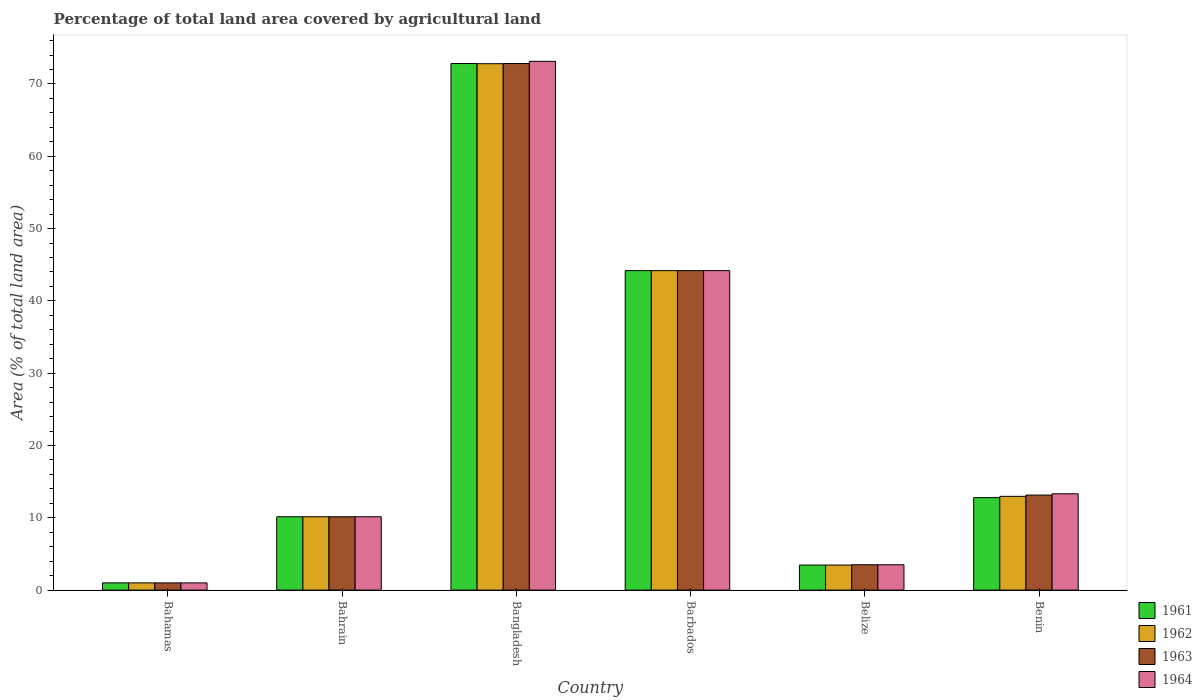Are the number of bars on each tick of the X-axis equal?
Provide a short and direct response. Yes. What is the label of the 1st group of bars from the left?
Keep it short and to the point. Bahamas. What is the percentage of agricultural land in 1962 in Barbados?
Offer a very short reply. 44.19. Across all countries, what is the maximum percentage of agricultural land in 1963?
Give a very brief answer. 72.83. Across all countries, what is the minimum percentage of agricultural land in 1964?
Your answer should be compact. 1. In which country was the percentage of agricultural land in 1964 maximum?
Keep it short and to the point. Bangladesh. In which country was the percentage of agricultural land in 1961 minimum?
Keep it short and to the point. Bahamas. What is the total percentage of agricultural land in 1961 in the graph?
Your answer should be compact. 144.41. What is the difference between the percentage of agricultural land in 1962 in Bahamas and that in Bangladesh?
Your answer should be very brief. -71.81. What is the difference between the percentage of agricultural land in 1962 in Belize and the percentage of agricultural land in 1964 in Bangladesh?
Your answer should be very brief. -69.67. What is the average percentage of agricultural land in 1964 per country?
Your response must be concise. 24.22. What is the ratio of the percentage of agricultural land in 1963 in Bangladesh to that in Benin?
Offer a terse response. 5.54. What is the difference between the highest and the second highest percentage of agricultural land in 1961?
Make the answer very short. 28.64. What is the difference between the highest and the lowest percentage of agricultural land in 1963?
Provide a short and direct response. 71.83. In how many countries, is the percentage of agricultural land in 1961 greater than the average percentage of agricultural land in 1961 taken over all countries?
Your answer should be compact. 2. Is the sum of the percentage of agricultural land in 1961 in Bangladesh and Barbados greater than the maximum percentage of agricultural land in 1964 across all countries?
Your answer should be compact. Yes. Is it the case that in every country, the sum of the percentage of agricultural land in 1961 and percentage of agricultural land in 1963 is greater than the sum of percentage of agricultural land in 1962 and percentage of agricultural land in 1964?
Your answer should be compact. No. Is it the case that in every country, the sum of the percentage of agricultural land in 1962 and percentage of agricultural land in 1964 is greater than the percentage of agricultural land in 1963?
Your response must be concise. Yes. What is the difference between two consecutive major ticks on the Y-axis?
Make the answer very short. 10. Are the values on the major ticks of Y-axis written in scientific E-notation?
Your answer should be compact. No. Does the graph contain any zero values?
Provide a short and direct response. No. Does the graph contain grids?
Your answer should be very brief. No. Where does the legend appear in the graph?
Ensure brevity in your answer.  Bottom right. How many legend labels are there?
Make the answer very short. 4. What is the title of the graph?
Give a very brief answer. Percentage of total land area covered by agricultural land. What is the label or title of the X-axis?
Provide a short and direct response. Country. What is the label or title of the Y-axis?
Ensure brevity in your answer.  Area (% of total land area). What is the Area (% of total land area) in 1961 in Bahamas?
Ensure brevity in your answer.  1. What is the Area (% of total land area) in 1962 in Bahamas?
Provide a succinct answer. 1. What is the Area (% of total land area) of 1963 in Bahamas?
Offer a very short reply. 1. What is the Area (% of total land area) in 1964 in Bahamas?
Keep it short and to the point. 1. What is the Area (% of total land area) in 1961 in Bahrain?
Your answer should be very brief. 10.14. What is the Area (% of total land area) of 1962 in Bahrain?
Keep it short and to the point. 10.14. What is the Area (% of total land area) of 1963 in Bahrain?
Provide a succinct answer. 10.14. What is the Area (% of total land area) in 1964 in Bahrain?
Your answer should be compact. 10.14. What is the Area (% of total land area) in 1961 in Bangladesh?
Your answer should be compact. 72.83. What is the Area (% of total land area) of 1962 in Bangladesh?
Provide a short and direct response. 72.8. What is the Area (% of total land area) of 1963 in Bangladesh?
Make the answer very short. 72.83. What is the Area (% of total land area) of 1964 in Bangladesh?
Offer a terse response. 73.14. What is the Area (% of total land area) of 1961 in Barbados?
Your answer should be very brief. 44.19. What is the Area (% of total land area) of 1962 in Barbados?
Offer a terse response. 44.19. What is the Area (% of total land area) in 1963 in Barbados?
Provide a succinct answer. 44.19. What is the Area (% of total land area) in 1964 in Barbados?
Offer a terse response. 44.19. What is the Area (% of total land area) of 1961 in Belize?
Give a very brief answer. 3.46. What is the Area (% of total land area) of 1962 in Belize?
Offer a terse response. 3.46. What is the Area (% of total land area) of 1963 in Belize?
Provide a succinct answer. 3.51. What is the Area (% of total land area) in 1964 in Belize?
Your response must be concise. 3.51. What is the Area (% of total land area) in 1961 in Benin?
Provide a short and direct response. 12.79. What is the Area (% of total land area) of 1962 in Benin?
Provide a succinct answer. 12.97. What is the Area (% of total land area) in 1963 in Benin?
Your response must be concise. 13.14. What is the Area (% of total land area) in 1964 in Benin?
Provide a succinct answer. 13.32. Across all countries, what is the maximum Area (% of total land area) in 1961?
Keep it short and to the point. 72.83. Across all countries, what is the maximum Area (% of total land area) of 1962?
Provide a short and direct response. 72.8. Across all countries, what is the maximum Area (% of total land area) in 1963?
Offer a very short reply. 72.83. Across all countries, what is the maximum Area (% of total land area) of 1964?
Provide a succinct answer. 73.14. Across all countries, what is the minimum Area (% of total land area) of 1961?
Provide a short and direct response. 1. Across all countries, what is the minimum Area (% of total land area) in 1962?
Your answer should be compact. 1. Across all countries, what is the minimum Area (% of total land area) in 1963?
Provide a succinct answer. 1. Across all countries, what is the minimum Area (% of total land area) of 1964?
Ensure brevity in your answer.  1. What is the total Area (% of total land area) of 1961 in the graph?
Your response must be concise. 144.41. What is the total Area (% of total land area) in 1962 in the graph?
Ensure brevity in your answer.  144.56. What is the total Area (% of total land area) in 1963 in the graph?
Provide a succinct answer. 144.81. What is the total Area (% of total land area) in 1964 in the graph?
Your answer should be compact. 145.29. What is the difference between the Area (% of total land area) of 1961 in Bahamas and that in Bahrain?
Your answer should be very brief. -9.15. What is the difference between the Area (% of total land area) of 1962 in Bahamas and that in Bahrain?
Make the answer very short. -9.15. What is the difference between the Area (% of total land area) of 1963 in Bahamas and that in Bahrain?
Your response must be concise. -9.15. What is the difference between the Area (% of total land area) of 1964 in Bahamas and that in Bahrain?
Provide a succinct answer. -9.15. What is the difference between the Area (% of total land area) in 1961 in Bahamas and that in Bangladesh?
Provide a short and direct response. -71.83. What is the difference between the Area (% of total land area) of 1962 in Bahamas and that in Bangladesh?
Offer a very short reply. -71.81. What is the difference between the Area (% of total land area) in 1963 in Bahamas and that in Bangladesh?
Offer a very short reply. -71.83. What is the difference between the Area (% of total land area) in 1964 in Bahamas and that in Bangladesh?
Make the answer very short. -72.14. What is the difference between the Area (% of total land area) of 1961 in Bahamas and that in Barbados?
Offer a terse response. -43.19. What is the difference between the Area (% of total land area) of 1962 in Bahamas and that in Barbados?
Give a very brief answer. -43.19. What is the difference between the Area (% of total land area) in 1963 in Bahamas and that in Barbados?
Keep it short and to the point. -43.19. What is the difference between the Area (% of total land area) of 1964 in Bahamas and that in Barbados?
Your response must be concise. -43.19. What is the difference between the Area (% of total land area) of 1961 in Bahamas and that in Belize?
Provide a short and direct response. -2.46. What is the difference between the Area (% of total land area) in 1962 in Bahamas and that in Belize?
Your answer should be compact. -2.46. What is the difference between the Area (% of total land area) in 1963 in Bahamas and that in Belize?
Give a very brief answer. -2.51. What is the difference between the Area (% of total land area) in 1964 in Bahamas and that in Belize?
Your answer should be compact. -2.51. What is the difference between the Area (% of total land area) in 1961 in Bahamas and that in Benin?
Make the answer very short. -11.79. What is the difference between the Area (% of total land area) of 1962 in Bahamas and that in Benin?
Provide a short and direct response. -11.97. What is the difference between the Area (% of total land area) in 1963 in Bahamas and that in Benin?
Give a very brief answer. -12.14. What is the difference between the Area (% of total land area) in 1964 in Bahamas and that in Benin?
Keep it short and to the point. -12.32. What is the difference between the Area (% of total land area) in 1961 in Bahrain and that in Bangladesh?
Give a very brief answer. -62.68. What is the difference between the Area (% of total land area) in 1962 in Bahrain and that in Bangladesh?
Ensure brevity in your answer.  -62.66. What is the difference between the Area (% of total land area) of 1963 in Bahrain and that in Bangladesh?
Keep it short and to the point. -62.68. What is the difference between the Area (% of total land area) of 1964 in Bahrain and that in Bangladesh?
Make the answer very short. -62.99. What is the difference between the Area (% of total land area) in 1961 in Bahrain and that in Barbados?
Offer a terse response. -34.04. What is the difference between the Area (% of total land area) in 1962 in Bahrain and that in Barbados?
Your answer should be compact. -34.04. What is the difference between the Area (% of total land area) in 1963 in Bahrain and that in Barbados?
Your response must be concise. -34.04. What is the difference between the Area (% of total land area) of 1964 in Bahrain and that in Barbados?
Give a very brief answer. -34.04. What is the difference between the Area (% of total land area) in 1961 in Bahrain and that in Belize?
Make the answer very short. 6.68. What is the difference between the Area (% of total land area) in 1962 in Bahrain and that in Belize?
Offer a terse response. 6.68. What is the difference between the Area (% of total land area) of 1963 in Bahrain and that in Belize?
Provide a short and direct response. 6.64. What is the difference between the Area (% of total land area) of 1964 in Bahrain and that in Belize?
Give a very brief answer. 6.64. What is the difference between the Area (% of total land area) of 1961 in Bahrain and that in Benin?
Make the answer very short. -2.64. What is the difference between the Area (% of total land area) of 1962 in Bahrain and that in Benin?
Keep it short and to the point. -2.82. What is the difference between the Area (% of total land area) in 1963 in Bahrain and that in Benin?
Provide a succinct answer. -3. What is the difference between the Area (% of total land area) of 1964 in Bahrain and that in Benin?
Offer a very short reply. -3.18. What is the difference between the Area (% of total land area) in 1961 in Bangladesh and that in Barbados?
Your response must be concise. 28.64. What is the difference between the Area (% of total land area) of 1962 in Bangladesh and that in Barbados?
Give a very brief answer. 28.62. What is the difference between the Area (% of total land area) in 1963 in Bangladesh and that in Barbados?
Make the answer very short. 28.64. What is the difference between the Area (% of total land area) in 1964 in Bangladesh and that in Barbados?
Your answer should be very brief. 28.95. What is the difference between the Area (% of total land area) in 1961 in Bangladesh and that in Belize?
Keep it short and to the point. 69.36. What is the difference between the Area (% of total land area) of 1962 in Bangladesh and that in Belize?
Give a very brief answer. 69.34. What is the difference between the Area (% of total land area) of 1963 in Bangladesh and that in Belize?
Keep it short and to the point. 69.32. What is the difference between the Area (% of total land area) in 1964 in Bangladesh and that in Belize?
Your response must be concise. 69.63. What is the difference between the Area (% of total land area) of 1961 in Bangladesh and that in Benin?
Make the answer very short. 60.04. What is the difference between the Area (% of total land area) of 1962 in Bangladesh and that in Benin?
Provide a short and direct response. 59.84. What is the difference between the Area (% of total land area) of 1963 in Bangladesh and that in Benin?
Provide a short and direct response. 59.68. What is the difference between the Area (% of total land area) in 1964 in Bangladesh and that in Benin?
Your answer should be compact. 59.81. What is the difference between the Area (% of total land area) of 1961 in Barbados and that in Belize?
Offer a very short reply. 40.72. What is the difference between the Area (% of total land area) of 1962 in Barbados and that in Belize?
Give a very brief answer. 40.72. What is the difference between the Area (% of total land area) in 1963 in Barbados and that in Belize?
Offer a terse response. 40.68. What is the difference between the Area (% of total land area) in 1964 in Barbados and that in Belize?
Your response must be concise. 40.68. What is the difference between the Area (% of total land area) in 1961 in Barbados and that in Benin?
Offer a very short reply. 31.4. What is the difference between the Area (% of total land area) of 1962 in Barbados and that in Benin?
Your answer should be very brief. 31.22. What is the difference between the Area (% of total land area) of 1963 in Barbados and that in Benin?
Offer a very short reply. 31.04. What is the difference between the Area (% of total land area) of 1964 in Barbados and that in Benin?
Make the answer very short. 30.87. What is the difference between the Area (% of total land area) in 1961 in Belize and that in Benin?
Keep it short and to the point. -9.32. What is the difference between the Area (% of total land area) in 1962 in Belize and that in Benin?
Give a very brief answer. -9.5. What is the difference between the Area (% of total land area) of 1963 in Belize and that in Benin?
Make the answer very short. -9.64. What is the difference between the Area (% of total land area) of 1964 in Belize and that in Benin?
Offer a very short reply. -9.81. What is the difference between the Area (% of total land area) in 1961 in Bahamas and the Area (% of total land area) in 1962 in Bahrain?
Your answer should be very brief. -9.15. What is the difference between the Area (% of total land area) in 1961 in Bahamas and the Area (% of total land area) in 1963 in Bahrain?
Give a very brief answer. -9.15. What is the difference between the Area (% of total land area) in 1961 in Bahamas and the Area (% of total land area) in 1964 in Bahrain?
Offer a very short reply. -9.15. What is the difference between the Area (% of total land area) in 1962 in Bahamas and the Area (% of total land area) in 1963 in Bahrain?
Provide a short and direct response. -9.15. What is the difference between the Area (% of total land area) in 1962 in Bahamas and the Area (% of total land area) in 1964 in Bahrain?
Your answer should be compact. -9.15. What is the difference between the Area (% of total land area) of 1963 in Bahamas and the Area (% of total land area) of 1964 in Bahrain?
Keep it short and to the point. -9.15. What is the difference between the Area (% of total land area) in 1961 in Bahamas and the Area (% of total land area) in 1962 in Bangladesh?
Provide a short and direct response. -71.81. What is the difference between the Area (% of total land area) in 1961 in Bahamas and the Area (% of total land area) in 1963 in Bangladesh?
Offer a terse response. -71.83. What is the difference between the Area (% of total land area) of 1961 in Bahamas and the Area (% of total land area) of 1964 in Bangladesh?
Keep it short and to the point. -72.14. What is the difference between the Area (% of total land area) of 1962 in Bahamas and the Area (% of total land area) of 1963 in Bangladesh?
Your answer should be very brief. -71.83. What is the difference between the Area (% of total land area) in 1962 in Bahamas and the Area (% of total land area) in 1964 in Bangladesh?
Your answer should be compact. -72.14. What is the difference between the Area (% of total land area) of 1963 in Bahamas and the Area (% of total land area) of 1964 in Bangladesh?
Offer a terse response. -72.14. What is the difference between the Area (% of total land area) of 1961 in Bahamas and the Area (% of total land area) of 1962 in Barbados?
Provide a succinct answer. -43.19. What is the difference between the Area (% of total land area) in 1961 in Bahamas and the Area (% of total land area) in 1963 in Barbados?
Provide a short and direct response. -43.19. What is the difference between the Area (% of total land area) of 1961 in Bahamas and the Area (% of total land area) of 1964 in Barbados?
Ensure brevity in your answer.  -43.19. What is the difference between the Area (% of total land area) in 1962 in Bahamas and the Area (% of total land area) in 1963 in Barbados?
Your answer should be very brief. -43.19. What is the difference between the Area (% of total land area) in 1962 in Bahamas and the Area (% of total land area) in 1964 in Barbados?
Provide a short and direct response. -43.19. What is the difference between the Area (% of total land area) in 1963 in Bahamas and the Area (% of total land area) in 1964 in Barbados?
Give a very brief answer. -43.19. What is the difference between the Area (% of total land area) in 1961 in Bahamas and the Area (% of total land area) in 1962 in Belize?
Provide a short and direct response. -2.46. What is the difference between the Area (% of total land area) in 1961 in Bahamas and the Area (% of total land area) in 1963 in Belize?
Offer a terse response. -2.51. What is the difference between the Area (% of total land area) in 1961 in Bahamas and the Area (% of total land area) in 1964 in Belize?
Ensure brevity in your answer.  -2.51. What is the difference between the Area (% of total land area) of 1962 in Bahamas and the Area (% of total land area) of 1963 in Belize?
Give a very brief answer. -2.51. What is the difference between the Area (% of total land area) in 1962 in Bahamas and the Area (% of total land area) in 1964 in Belize?
Your response must be concise. -2.51. What is the difference between the Area (% of total land area) of 1963 in Bahamas and the Area (% of total land area) of 1964 in Belize?
Ensure brevity in your answer.  -2.51. What is the difference between the Area (% of total land area) in 1961 in Bahamas and the Area (% of total land area) in 1962 in Benin?
Offer a terse response. -11.97. What is the difference between the Area (% of total land area) of 1961 in Bahamas and the Area (% of total land area) of 1963 in Benin?
Provide a short and direct response. -12.14. What is the difference between the Area (% of total land area) in 1961 in Bahamas and the Area (% of total land area) in 1964 in Benin?
Ensure brevity in your answer.  -12.32. What is the difference between the Area (% of total land area) of 1962 in Bahamas and the Area (% of total land area) of 1963 in Benin?
Your answer should be compact. -12.14. What is the difference between the Area (% of total land area) in 1962 in Bahamas and the Area (% of total land area) in 1964 in Benin?
Ensure brevity in your answer.  -12.32. What is the difference between the Area (% of total land area) in 1963 in Bahamas and the Area (% of total land area) in 1964 in Benin?
Your response must be concise. -12.32. What is the difference between the Area (% of total land area) in 1961 in Bahrain and the Area (% of total land area) in 1962 in Bangladesh?
Provide a short and direct response. -62.66. What is the difference between the Area (% of total land area) in 1961 in Bahrain and the Area (% of total land area) in 1963 in Bangladesh?
Ensure brevity in your answer.  -62.68. What is the difference between the Area (% of total land area) of 1961 in Bahrain and the Area (% of total land area) of 1964 in Bangladesh?
Offer a very short reply. -62.99. What is the difference between the Area (% of total land area) in 1962 in Bahrain and the Area (% of total land area) in 1963 in Bangladesh?
Provide a short and direct response. -62.68. What is the difference between the Area (% of total land area) of 1962 in Bahrain and the Area (% of total land area) of 1964 in Bangladesh?
Ensure brevity in your answer.  -62.99. What is the difference between the Area (% of total land area) of 1963 in Bahrain and the Area (% of total land area) of 1964 in Bangladesh?
Make the answer very short. -62.99. What is the difference between the Area (% of total land area) in 1961 in Bahrain and the Area (% of total land area) in 1962 in Barbados?
Provide a short and direct response. -34.04. What is the difference between the Area (% of total land area) in 1961 in Bahrain and the Area (% of total land area) in 1963 in Barbados?
Keep it short and to the point. -34.04. What is the difference between the Area (% of total land area) of 1961 in Bahrain and the Area (% of total land area) of 1964 in Barbados?
Your response must be concise. -34.04. What is the difference between the Area (% of total land area) of 1962 in Bahrain and the Area (% of total land area) of 1963 in Barbados?
Provide a short and direct response. -34.04. What is the difference between the Area (% of total land area) of 1962 in Bahrain and the Area (% of total land area) of 1964 in Barbados?
Ensure brevity in your answer.  -34.04. What is the difference between the Area (% of total land area) of 1963 in Bahrain and the Area (% of total land area) of 1964 in Barbados?
Make the answer very short. -34.04. What is the difference between the Area (% of total land area) in 1961 in Bahrain and the Area (% of total land area) in 1962 in Belize?
Provide a short and direct response. 6.68. What is the difference between the Area (% of total land area) of 1961 in Bahrain and the Area (% of total land area) of 1963 in Belize?
Offer a terse response. 6.64. What is the difference between the Area (% of total land area) of 1961 in Bahrain and the Area (% of total land area) of 1964 in Belize?
Ensure brevity in your answer.  6.64. What is the difference between the Area (% of total land area) of 1962 in Bahrain and the Area (% of total land area) of 1963 in Belize?
Your answer should be compact. 6.64. What is the difference between the Area (% of total land area) of 1962 in Bahrain and the Area (% of total land area) of 1964 in Belize?
Your answer should be compact. 6.64. What is the difference between the Area (% of total land area) of 1963 in Bahrain and the Area (% of total land area) of 1964 in Belize?
Your response must be concise. 6.64. What is the difference between the Area (% of total land area) of 1961 in Bahrain and the Area (% of total land area) of 1962 in Benin?
Offer a very short reply. -2.82. What is the difference between the Area (% of total land area) of 1961 in Bahrain and the Area (% of total land area) of 1963 in Benin?
Offer a very short reply. -3. What is the difference between the Area (% of total land area) in 1961 in Bahrain and the Area (% of total land area) in 1964 in Benin?
Make the answer very short. -3.18. What is the difference between the Area (% of total land area) of 1962 in Bahrain and the Area (% of total land area) of 1963 in Benin?
Provide a short and direct response. -3. What is the difference between the Area (% of total land area) of 1962 in Bahrain and the Area (% of total land area) of 1964 in Benin?
Offer a terse response. -3.18. What is the difference between the Area (% of total land area) in 1963 in Bahrain and the Area (% of total land area) in 1964 in Benin?
Provide a short and direct response. -3.18. What is the difference between the Area (% of total land area) of 1961 in Bangladesh and the Area (% of total land area) of 1962 in Barbados?
Offer a very short reply. 28.64. What is the difference between the Area (% of total land area) in 1961 in Bangladesh and the Area (% of total land area) in 1963 in Barbados?
Ensure brevity in your answer.  28.64. What is the difference between the Area (% of total land area) of 1961 in Bangladesh and the Area (% of total land area) of 1964 in Barbados?
Provide a short and direct response. 28.64. What is the difference between the Area (% of total land area) in 1962 in Bangladesh and the Area (% of total land area) in 1963 in Barbados?
Provide a short and direct response. 28.62. What is the difference between the Area (% of total land area) of 1962 in Bangladesh and the Area (% of total land area) of 1964 in Barbados?
Provide a short and direct response. 28.62. What is the difference between the Area (% of total land area) of 1963 in Bangladesh and the Area (% of total land area) of 1964 in Barbados?
Your response must be concise. 28.64. What is the difference between the Area (% of total land area) of 1961 in Bangladesh and the Area (% of total land area) of 1962 in Belize?
Provide a succinct answer. 69.36. What is the difference between the Area (% of total land area) of 1961 in Bangladesh and the Area (% of total land area) of 1963 in Belize?
Your answer should be very brief. 69.32. What is the difference between the Area (% of total land area) in 1961 in Bangladesh and the Area (% of total land area) in 1964 in Belize?
Provide a short and direct response. 69.32. What is the difference between the Area (% of total land area) of 1962 in Bangladesh and the Area (% of total land area) of 1963 in Belize?
Make the answer very short. 69.3. What is the difference between the Area (% of total land area) in 1962 in Bangladesh and the Area (% of total land area) in 1964 in Belize?
Make the answer very short. 69.3. What is the difference between the Area (% of total land area) in 1963 in Bangladesh and the Area (% of total land area) in 1964 in Belize?
Offer a very short reply. 69.32. What is the difference between the Area (% of total land area) in 1961 in Bangladesh and the Area (% of total land area) in 1962 in Benin?
Ensure brevity in your answer.  59.86. What is the difference between the Area (% of total land area) of 1961 in Bangladesh and the Area (% of total land area) of 1963 in Benin?
Your response must be concise. 59.68. What is the difference between the Area (% of total land area) in 1961 in Bangladesh and the Area (% of total land area) in 1964 in Benin?
Provide a succinct answer. 59.51. What is the difference between the Area (% of total land area) in 1962 in Bangladesh and the Area (% of total land area) in 1963 in Benin?
Your response must be concise. 59.66. What is the difference between the Area (% of total land area) in 1962 in Bangladesh and the Area (% of total land area) in 1964 in Benin?
Keep it short and to the point. 59.48. What is the difference between the Area (% of total land area) in 1963 in Bangladesh and the Area (% of total land area) in 1964 in Benin?
Your answer should be compact. 59.51. What is the difference between the Area (% of total land area) of 1961 in Barbados and the Area (% of total land area) of 1962 in Belize?
Give a very brief answer. 40.72. What is the difference between the Area (% of total land area) of 1961 in Barbados and the Area (% of total land area) of 1963 in Belize?
Provide a short and direct response. 40.68. What is the difference between the Area (% of total land area) of 1961 in Barbados and the Area (% of total land area) of 1964 in Belize?
Ensure brevity in your answer.  40.68. What is the difference between the Area (% of total land area) in 1962 in Barbados and the Area (% of total land area) in 1963 in Belize?
Offer a very short reply. 40.68. What is the difference between the Area (% of total land area) of 1962 in Barbados and the Area (% of total land area) of 1964 in Belize?
Give a very brief answer. 40.68. What is the difference between the Area (% of total land area) of 1963 in Barbados and the Area (% of total land area) of 1964 in Belize?
Keep it short and to the point. 40.68. What is the difference between the Area (% of total land area) in 1961 in Barbados and the Area (% of total land area) in 1962 in Benin?
Make the answer very short. 31.22. What is the difference between the Area (% of total land area) of 1961 in Barbados and the Area (% of total land area) of 1963 in Benin?
Give a very brief answer. 31.04. What is the difference between the Area (% of total land area) in 1961 in Barbados and the Area (% of total land area) in 1964 in Benin?
Make the answer very short. 30.87. What is the difference between the Area (% of total land area) in 1962 in Barbados and the Area (% of total land area) in 1963 in Benin?
Provide a short and direct response. 31.04. What is the difference between the Area (% of total land area) of 1962 in Barbados and the Area (% of total land area) of 1964 in Benin?
Your answer should be compact. 30.87. What is the difference between the Area (% of total land area) in 1963 in Barbados and the Area (% of total land area) in 1964 in Benin?
Ensure brevity in your answer.  30.87. What is the difference between the Area (% of total land area) of 1961 in Belize and the Area (% of total land area) of 1962 in Benin?
Offer a very short reply. -9.5. What is the difference between the Area (% of total land area) of 1961 in Belize and the Area (% of total land area) of 1963 in Benin?
Keep it short and to the point. -9.68. What is the difference between the Area (% of total land area) of 1961 in Belize and the Area (% of total land area) of 1964 in Benin?
Your response must be concise. -9.86. What is the difference between the Area (% of total land area) of 1962 in Belize and the Area (% of total land area) of 1963 in Benin?
Your response must be concise. -9.68. What is the difference between the Area (% of total land area) in 1962 in Belize and the Area (% of total land area) in 1964 in Benin?
Give a very brief answer. -9.86. What is the difference between the Area (% of total land area) in 1963 in Belize and the Area (% of total land area) in 1964 in Benin?
Ensure brevity in your answer.  -9.81. What is the average Area (% of total land area) of 1961 per country?
Your response must be concise. 24.07. What is the average Area (% of total land area) in 1962 per country?
Offer a very short reply. 24.09. What is the average Area (% of total land area) in 1963 per country?
Your answer should be very brief. 24.13. What is the average Area (% of total land area) in 1964 per country?
Offer a very short reply. 24.22. What is the difference between the Area (% of total land area) in 1961 and Area (% of total land area) in 1963 in Bahamas?
Make the answer very short. 0. What is the difference between the Area (% of total land area) in 1962 and Area (% of total land area) in 1964 in Bahamas?
Give a very brief answer. 0. What is the difference between the Area (% of total land area) of 1963 and Area (% of total land area) of 1964 in Bahamas?
Your answer should be compact. 0. What is the difference between the Area (% of total land area) in 1961 and Area (% of total land area) in 1963 in Bahrain?
Give a very brief answer. 0. What is the difference between the Area (% of total land area) in 1962 and Area (% of total land area) in 1963 in Bahrain?
Your answer should be compact. 0. What is the difference between the Area (% of total land area) of 1962 and Area (% of total land area) of 1964 in Bahrain?
Your response must be concise. 0. What is the difference between the Area (% of total land area) of 1963 and Area (% of total land area) of 1964 in Bahrain?
Your answer should be compact. 0. What is the difference between the Area (% of total land area) of 1961 and Area (% of total land area) of 1962 in Bangladesh?
Ensure brevity in your answer.  0.02. What is the difference between the Area (% of total land area) of 1961 and Area (% of total land area) of 1963 in Bangladesh?
Provide a succinct answer. 0. What is the difference between the Area (% of total land area) in 1961 and Area (% of total land area) in 1964 in Bangladesh?
Provide a short and direct response. -0.31. What is the difference between the Area (% of total land area) of 1962 and Area (% of total land area) of 1963 in Bangladesh?
Your answer should be compact. -0.02. What is the difference between the Area (% of total land area) of 1962 and Area (% of total land area) of 1964 in Bangladesh?
Your answer should be very brief. -0.33. What is the difference between the Area (% of total land area) in 1963 and Area (% of total land area) in 1964 in Bangladesh?
Your answer should be very brief. -0.31. What is the difference between the Area (% of total land area) in 1961 and Area (% of total land area) in 1963 in Barbados?
Provide a succinct answer. 0. What is the difference between the Area (% of total land area) in 1962 and Area (% of total land area) in 1964 in Barbados?
Provide a succinct answer. 0. What is the difference between the Area (% of total land area) in 1961 and Area (% of total land area) in 1963 in Belize?
Make the answer very short. -0.04. What is the difference between the Area (% of total land area) of 1961 and Area (% of total land area) of 1964 in Belize?
Your answer should be compact. -0.04. What is the difference between the Area (% of total land area) of 1962 and Area (% of total land area) of 1963 in Belize?
Your answer should be very brief. -0.04. What is the difference between the Area (% of total land area) of 1962 and Area (% of total land area) of 1964 in Belize?
Your response must be concise. -0.04. What is the difference between the Area (% of total land area) of 1961 and Area (% of total land area) of 1962 in Benin?
Your response must be concise. -0.18. What is the difference between the Area (% of total land area) of 1961 and Area (% of total land area) of 1963 in Benin?
Your response must be concise. -0.35. What is the difference between the Area (% of total land area) of 1961 and Area (% of total land area) of 1964 in Benin?
Your answer should be compact. -0.53. What is the difference between the Area (% of total land area) in 1962 and Area (% of total land area) in 1963 in Benin?
Make the answer very short. -0.18. What is the difference between the Area (% of total land area) of 1962 and Area (% of total land area) of 1964 in Benin?
Your answer should be compact. -0.35. What is the difference between the Area (% of total land area) of 1963 and Area (% of total land area) of 1964 in Benin?
Your answer should be very brief. -0.18. What is the ratio of the Area (% of total land area) of 1961 in Bahamas to that in Bahrain?
Provide a succinct answer. 0.1. What is the ratio of the Area (% of total land area) of 1962 in Bahamas to that in Bahrain?
Ensure brevity in your answer.  0.1. What is the ratio of the Area (% of total land area) of 1963 in Bahamas to that in Bahrain?
Your response must be concise. 0.1. What is the ratio of the Area (% of total land area) in 1964 in Bahamas to that in Bahrain?
Your response must be concise. 0.1. What is the ratio of the Area (% of total land area) of 1961 in Bahamas to that in Bangladesh?
Give a very brief answer. 0.01. What is the ratio of the Area (% of total land area) of 1962 in Bahamas to that in Bangladesh?
Keep it short and to the point. 0.01. What is the ratio of the Area (% of total land area) in 1963 in Bahamas to that in Bangladesh?
Your answer should be very brief. 0.01. What is the ratio of the Area (% of total land area) in 1964 in Bahamas to that in Bangladesh?
Offer a terse response. 0.01. What is the ratio of the Area (% of total land area) of 1961 in Bahamas to that in Barbados?
Your answer should be compact. 0.02. What is the ratio of the Area (% of total land area) of 1962 in Bahamas to that in Barbados?
Your answer should be very brief. 0.02. What is the ratio of the Area (% of total land area) in 1963 in Bahamas to that in Barbados?
Provide a short and direct response. 0.02. What is the ratio of the Area (% of total land area) in 1964 in Bahamas to that in Barbados?
Provide a succinct answer. 0.02. What is the ratio of the Area (% of total land area) in 1961 in Bahamas to that in Belize?
Offer a very short reply. 0.29. What is the ratio of the Area (% of total land area) of 1962 in Bahamas to that in Belize?
Give a very brief answer. 0.29. What is the ratio of the Area (% of total land area) of 1963 in Bahamas to that in Belize?
Offer a terse response. 0.28. What is the ratio of the Area (% of total land area) of 1964 in Bahamas to that in Belize?
Your answer should be compact. 0.28. What is the ratio of the Area (% of total land area) in 1961 in Bahamas to that in Benin?
Your response must be concise. 0.08. What is the ratio of the Area (% of total land area) of 1962 in Bahamas to that in Benin?
Provide a short and direct response. 0.08. What is the ratio of the Area (% of total land area) of 1963 in Bahamas to that in Benin?
Your answer should be compact. 0.08. What is the ratio of the Area (% of total land area) of 1964 in Bahamas to that in Benin?
Give a very brief answer. 0.07. What is the ratio of the Area (% of total land area) in 1961 in Bahrain to that in Bangladesh?
Provide a short and direct response. 0.14. What is the ratio of the Area (% of total land area) in 1962 in Bahrain to that in Bangladesh?
Offer a very short reply. 0.14. What is the ratio of the Area (% of total land area) of 1963 in Bahrain to that in Bangladesh?
Offer a terse response. 0.14. What is the ratio of the Area (% of total land area) of 1964 in Bahrain to that in Bangladesh?
Give a very brief answer. 0.14. What is the ratio of the Area (% of total land area) in 1961 in Bahrain to that in Barbados?
Your answer should be compact. 0.23. What is the ratio of the Area (% of total land area) of 1962 in Bahrain to that in Barbados?
Ensure brevity in your answer.  0.23. What is the ratio of the Area (% of total land area) in 1963 in Bahrain to that in Barbados?
Your answer should be compact. 0.23. What is the ratio of the Area (% of total land area) in 1964 in Bahrain to that in Barbados?
Offer a very short reply. 0.23. What is the ratio of the Area (% of total land area) in 1961 in Bahrain to that in Belize?
Offer a very short reply. 2.93. What is the ratio of the Area (% of total land area) in 1962 in Bahrain to that in Belize?
Ensure brevity in your answer.  2.93. What is the ratio of the Area (% of total land area) of 1963 in Bahrain to that in Belize?
Your answer should be very brief. 2.89. What is the ratio of the Area (% of total land area) of 1964 in Bahrain to that in Belize?
Keep it short and to the point. 2.89. What is the ratio of the Area (% of total land area) of 1961 in Bahrain to that in Benin?
Your response must be concise. 0.79. What is the ratio of the Area (% of total land area) of 1962 in Bahrain to that in Benin?
Make the answer very short. 0.78. What is the ratio of the Area (% of total land area) in 1963 in Bahrain to that in Benin?
Your response must be concise. 0.77. What is the ratio of the Area (% of total land area) of 1964 in Bahrain to that in Benin?
Your answer should be very brief. 0.76. What is the ratio of the Area (% of total land area) in 1961 in Bangladesh to that in Barbados?
Your response must be concise. 1.65. What is the ratio of the Area (% of total land area) in 1962 in Bangladesh to that in Barbados?
Your answer should be very brief. 1.65. What is the ratio of the Area (% of total land area) in 1963 in Bangladesh to that in Barbados?
Make the answer very short. 1.65. What is the ratio of the Area (% of total land area) in 1964 in Bangladesh to that in Barbados?
Keep it short and to the point. 1.66. What is the ratio of the Area (% of total land area) in 1961 in Bangladesh to that in Belize?
Your answer should be very brief. 21.03. What is the ratio of the Area (% of total land area) in 1962 in Bangladesh to that in Belize?
Ensure brevity in your answer.  21.02. What is the ratio of the Area (% of total land area) in 1963 in Bangladesh to that in Belize?
Make the answer very short. 20.77. What is the ratio of the Area (% of total land area) of 1964 in Bangladesh to that in Belize?
Keep it short and to the point. 20.85. What is the ratio of the Area (% of total land area) in 1961 in Bangladesh to that in Benin?
Make the answer very short. 5.69. What is the ratio of the Area (% of total land area) of 1962 in Bangladesh to that in Benin?
Provide a succinct answer. 5.62. What is the ratio of the Area (% of total land area) in 1963 in Bangladesh to that in Benin?
Make the answer very short. 5.54. What is the ratio of the Area (% of total land area) in 1964 in Bangladesh to that in Benin?
Ensure brevity in your answer.  5.49. What is the ratio of the Area (% of total land area) of 1961 in Barbados to that in Belize?
Your answer should be compact. 12.76. What is the ratio of the Area (% of total land area) in 1962 in Barbados to that in Belize?
Provide a succinct answer. 12.76. What is the ratio of the Area (% of total land area) in 1963 in Barbados to that in Belize?
Make the answer very short. 12.6. What is the ratio of the Area (% of total land area) of 1964 in Barbados to that in Belize?
Provide a succinct answer. 12.6. What is the ratio of the Area (% of total land area) in 1961 in Barbados to that in Benin?
Offer a very short reply. 3.46. What is the ratio of the Area (% of total land area) of 1962 in Barbados to that in Benin?
Your answer should be compact. 3.41. What is the ratio of the Area (% of total land area) of 1963 in Barbados to that in Benin?
Provide a succinct answer. 3.36. What is the ratio of the Area (% of total land area) in 1964 in Barbados to that in Benin?
Ensure brevity in your answer.  3.32. What is the ratio of the Area (% of total land area) in 1961 in Belize to that in Benin?
Your answer should be very brief. 0.27. What is the ratio of the Area (% of total land area) of 1962 in Belize to that in Benin?
Make the answer very short. 0.27. What is the ratio of the Area (% of total land area) in 1963 in Belize to that in Benin?
Your response must be concise. 0.27. What is the ratio of the Area (% of total land area) in 1964 in Belize to that in Benin?
Offer a terse response. 0.26. What is the difference between the highest and the second highest Area (% of total land area) of 1961?
Offer a very short reply. 28.64. What is the difference between the highest and the second highest Area (% of total land area) of 1962?
Ensure brevity in your answer.  28.62. What is the difference between the highest and the second highest Area (% of total land area) of 1963?
Provide a succinct answer. 28.64. What is the difference between the highest and the second highest Area (% of total land area) of 1964?
Provide a succinct answer. 28.95. What is the difference between the highest and the lowest Area (% of total land area) in 1961?
Offer a terse response. 71.83. What is the difference between the highest and the lowest Area (% of total land area) in 1962?
Your response must be concise. 71.81. What is the difference between the highest and the lowest Area (% of total land area) in 1963?
Offer a very short reply. 71.83. What is the difference between the highest and the lowest Area (% of total land area) of 1964?
Your answer should be very brief. 72.14. 